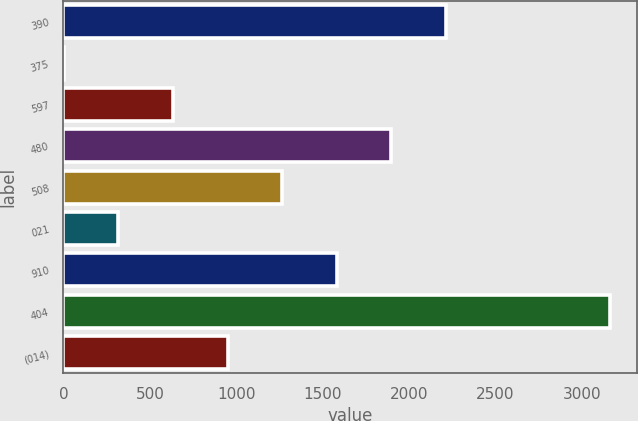Convert chart. <chart><loc_0><loc_0><loc_500><loc_500><bar_chart><fcel>390<fcel>375<fcel>597<fcel>480<fcel>508<fcel>021<fcel>910<fcel>404<fcel>(014)<nl><fcel>2214.05<fcel>2.26<fcel>634.2<fcel>1898.08<fcel>1266.14<fcel>318.23<fcel>1582.11<fcel>3162<fcel>950.17<nl></chart> 